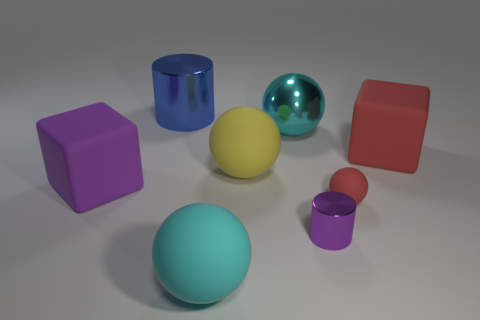Subtract all large yellow spheres. How many spheres are left? 3 Subtract all green cylinders. How many cyan balls are left? 2 Subtract all yellow balls. How many balls are left? 3 Subtract 1 balls. How many balls are left? 3 Add 1 tiny brown matte balls. How many objects exist? 9 Subtract all yellow balls. Subtract all red cylinders. How many balls are left? 3 Subtract all blocks. How many objects are left? 6 Add 1 large green metal spheres. How many large green metal spheres exist? 1 Subtract 0 red cylinders. How many objects are left? 8 Subtract all small gray matte balls. Subtract all big cyan rubber balls. How many objects are left? 7 